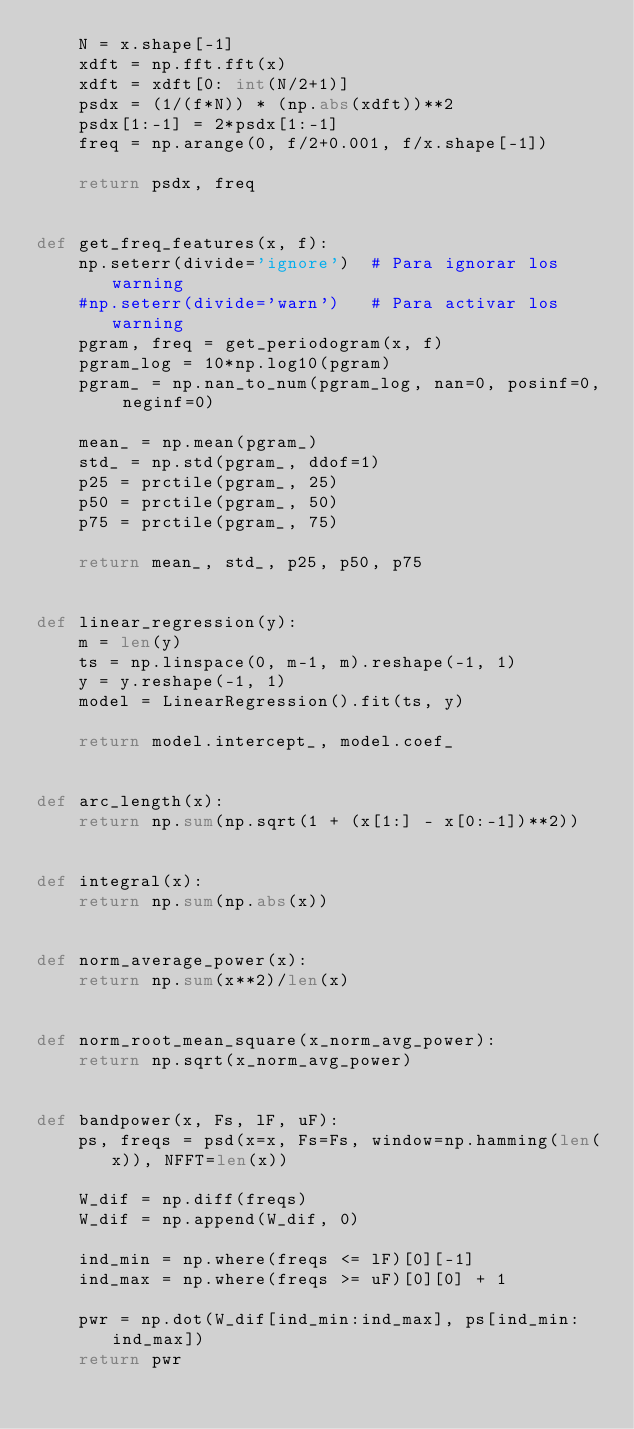Convert code to text. <code><loc_0><loc_0><loc_500><loc_500><_Python_>    N = x.shape[-1]
    xdft = np.fft.fft(x)
    xdft = xdft[0: int(N/2+1)]
    psdx = (1/(f*N)) * (np.abs(xdft))**2
    psdx[1:-1] = 2*psdx[1:-1]
    freq = np.arange(0, f/2+0.001, f/x.shape[-1])

    return psdx, freq


def get_freq_features(x, f):
    np.seterr(divide='ignore')  # Para ignorar los warning
    #np.seterr(divide='warn')   # Para activar los warning
    pgram, freq = get_periodogram(x, f)
    pgram_log = 10*np.log10(pgram)
    pgram_ = np.nan_to_num(pgram_log, nan=0, posinf=0, neginf=0)

    mean_ = np.mean(pgram_)
    std_ = np.std(pgram_, ddof=1)
    p25 = prctile(pgram_, 25)
    p50 = prctile(pgram_, 50)
    p75 = prctile(pgram_, 75)

    return mean_, std_, p25, p50, p75


def linear_regression(y):
    m = len(y)
    ts = np.linspace(0, m-1, m).reshape(-1, 1)
    y = y.reshape(-1, 1)
    model = LinearRegression().fit(ts, y)

    return model.intercept_, model.coef_


def arc_length(x):
    return np.sum(np.sqrt(1 + (x[1:] - x[0:-1])**2))


def integral(x):
    return np.sum(np.abs(x))


def norm_average_power(x):
    return np.sum(x**2)/len(x)


def norm_root_mean_square(x_norm_avg_power):
    return np.sqrt(x_norm_avg_power)


def bandpower(x, Fs, lF, uF):
    ps, freqs = psd(x=x, Fs=Fs, window=np.hamming(len(x)), NFFT=len(x))

    W_dif = np.diff(freqs)
    W_dif = np.append(W_dif, 0)

    ind_min = np.where(freqs <= lF)[0][-1]
    ind_max = np.where(freqs >= uF)[0][0] + 1

    pwr = np.dot(W_dif[ind_min:ind_max], ps[ind_min:ind_max])
    return pwr


</code> 